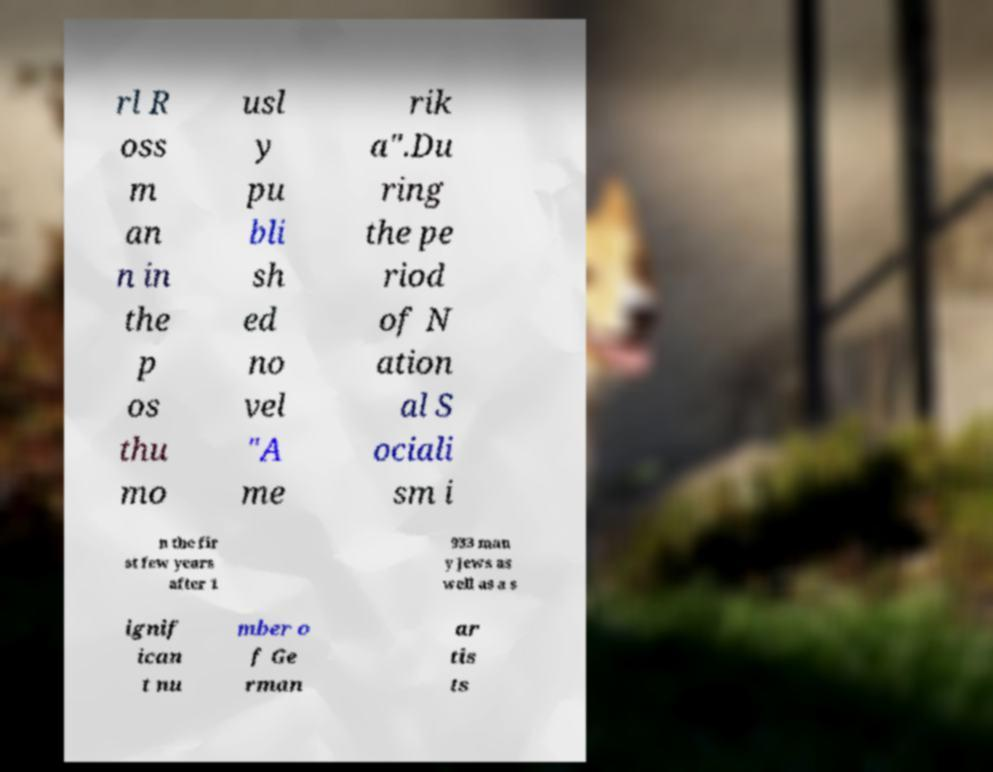There's text embedded in this image that I need extracted. Can you transcribe it verbatim? rl R oss m an n in the p os thu mo usl y pu bli sh ed no vel "A me rik a".Du ring the pe riod of N ation al S ociali sm i n the fir st few years after 1 933 man y Jews as well as a s ignif ican t nu mber o f Ge rman ar tis ts 